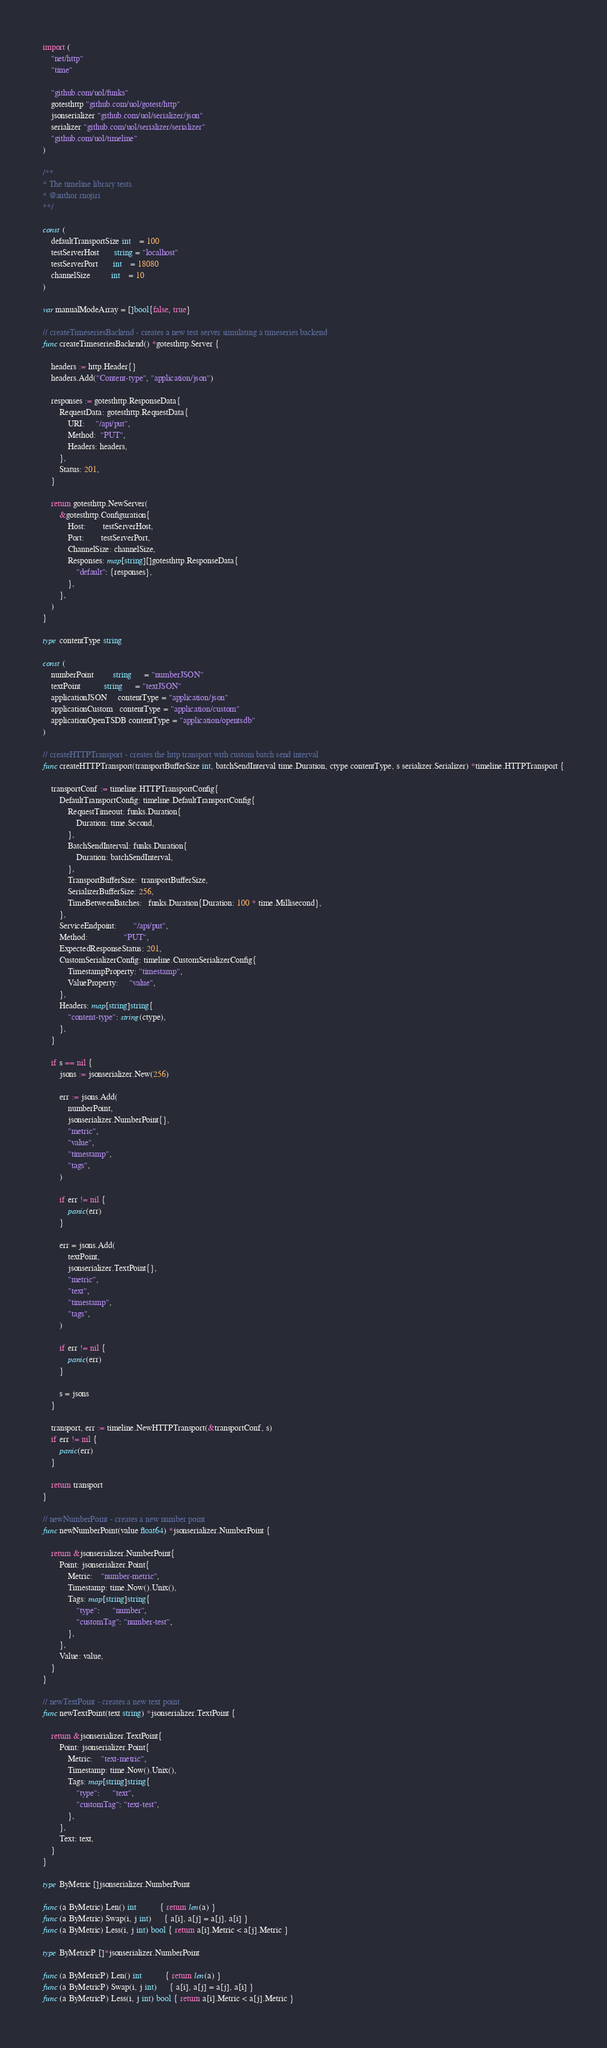<code> <loc_0><loc_0><loc_500><loc_500><_Go_>import (
	"net/http"
	"time"

	"github.com/uol/funks"
	gotesthttp "github.com/uol/gotest/http"
	jsonserializer "github.com/uol/serializer/json"
	serializer "github.com/uol/serializer/serializer"
	"github.com/uol/timeline"
)

/**
* The timeline library tests.
* @author rnojiri
**/

const (
	defaultTransportSize int    = 100
	testServerHost       string = "localhost"
	testServerPort       int    = 18080
	channelSize          int    = 10
)

var manualModeArray = []bool{false, true}

// createTimeseriesBackend - creates a new test server simulating a timeseries backend
func createTimeseriesBackend() *gotesthttp.Server {

	headers := http.Header{}
	headers.Add("Content-type", "application/json")

	responses := gotesthttp.ResponseData{
		RequestData: gotesthttp.RequestData{
			URI:     "/api/put",
			Method:  "PUT",
			Headers: headers,
		},
		Status: 201,
	}

	return gotesthttp.NewServer(
		&gotesthttp.Configuration{
			Host:        testServerHost,
			Port:        testServerPort,
			ChannelSize: channelSize,
			Responses: map[string][]gotesthttp.ResponseData{
				"default": {responses},
			},
		},
	)
}

type contentType string

const (
	numberPoint         string      = "numberJSON"
	textPoint           string      = "textJSON"
	applicationJSON     contentType = "application/json"
	applicationCustom   contentType = "application/custom"
	applicationOpenTSDB contentType = "application/opentsdb"
)

// createHTTPTransport - creates the http transport with custom batch send interval
func createHTTPTransport(transportBufferSize int, batchSendInterval time.Duration, ctype contentType, s serializer.Serializer) *timeline.HTTPTransport {

	transportConf := timeline.HTTPTransportConfig{
		DefaultTransportConfig: timeline.DefaultTransportConfig{
			RequestTimeout: funks.Duration{
				Duration: time.Second,
			},
			BatchSendInterval: funks.Duration{
				Duration: batchSendInterval,
			},
			TransportBufferSize:  transportBufferSize,
			SerializerBufferSize: 256,
			TimeBetweenBatches:   funks.Duration{Duration: 100 * time.Millisecond},
		},
		ServiceEndpoint:        "/api/put",
		Method:                 "PUT",
		ExpectedResponseStatus: 201,
		CustomSerializerConfig: timeline.CustomSerializerConfig{
			TimestampProperty: "timestamp",
			ValueProperty:     "value",
		},
		Headers: map[string]string{
			"content-type": string(ctype),
		},
	}

	if s == nil {
		jsons := jsonserializer.New(256)

		err := jsons.Add(
			numberPoint,
			jsonserializer.NumberPoint{},
			"metric",
			"value",
			"timestamp",
			"tags",
		)

		if err != nil {
			panic(err)
		}

		err = jsons.Add(
			textPoint,
			jsonserializer.TextPoint{},
			"metric",
			"text",
			"timestamp",
			"tags",
		)

		if err != nil {
			panic(err)
		}

		s = jsons
	}

	transport, err := timeline.NewHTTPTransport(&transportConf, s)
	if err != nil {
		panic(err)
	}

	return transport
}

// newNumberPoint - creates a new number point
func newNumberPoint(value float64) *jsonserializer.NumberPoint {

	return &jsonserializer.NumberPoint{
		Point: jsonserializer.Point{
			Metric:    "number-metric",
			Timestamp: time.Now().Unix(),
			Tags: map[string]string{
				"type":      "number",
				"customTag": "number-test",
			},
		},
		Value: value,
	}
}

// newTextPoint - creates a new text point
func newTextPoint(text string) *jsonserializer.TextPoint {

	return &jsonserializer.TextPoint{
		Point: jsonserializer.Point{
			Metric:    "text-metric",
			Timestamp: time.Now().Unix(),
			Tags: map[string]string{
				"type":      "text",
				"customTag": "text-test",
			},
		},
		Text: text,
	}
}

type ByMetric []jsonserializer.NumberPoint

func (a ByMetric) Len() int           { return len(a) }
func (a ByMetric) Swap(i, j int)      { a[i], a[j] = a[j], a[i] }
func (a ByMetric) Less(i, j int) bool { return a[i].Metric < a[j].Metric }

type ByMetricP []*jsonserializer.NumberPoint

func (a ByMetricP) Len() int           { return len(a) }
func (a ByMetricP) Swap(i, j int)      { a[i], a[j] = a[j], a[i] }
func (a ByMetricP) Less(i, j int) bool { return a[i].Metric < a[j].Metric }
</code> 